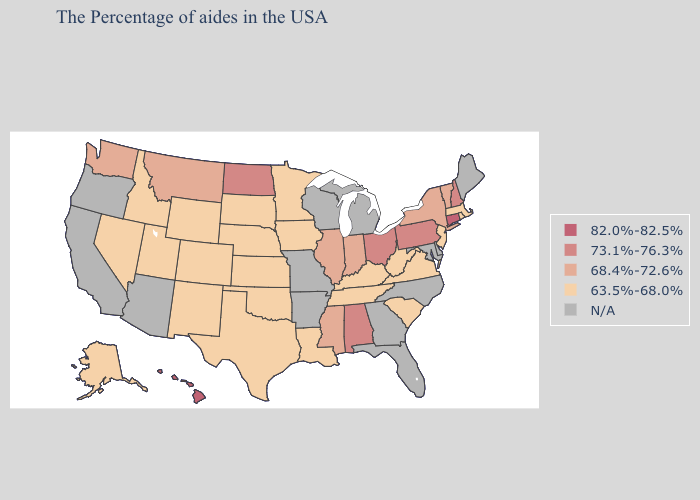Is the legend a continuous bar?
Answer briefly. No. What is the lowest value in the Northeast?
Write a very short answer. 63.5%-68.0%. Does Connecticut have the lowest value in the USA?
Write a very short answer. No. Which states have the highest value in the USA?
Short answer required. Connecticut, Hawaii. Is the legend a continuous bar?
Concise answer only. No. How many symbols are there in the legend?
Short answer required. 5. What is the value of North Dakota?
Be succinct. 73.1%-76.3%. Name the states that have a value in the range N/A?
Short answer required. Maine, Delaware, Maryland, North Carolina, Florida, Georgia, Michigan, Wisconsin, Missouri, Arkansas, Arizona, California, Oregon. What is the value of New York?
Concise answer only. 68.4%-72.6%. What is the lowest value in the South?
Write a very short answer. 63.5%-68.0%. Name the states that have a value in the range 82.0%-82.5%?
Answer briefly. Connecticut, Hawaii. What is the value of West Virginia?
Keep it brief. 63.5%-68.0%. 